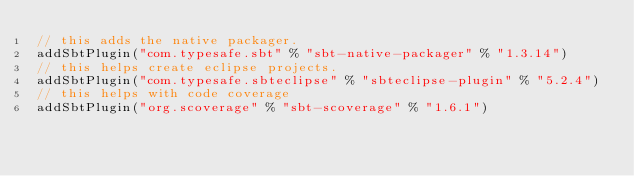Convert code to text. <code><loc_0><loc_0><loc_500><loc_500><_Scala_>// this adds the native packager.
addSbtPlugin("com.typesafe.sbt" % "sbt-native-packager" % "1.3.14")
// this helps create eclipse projects.
addSbtPlugin("com.typesafe.sbteclipse" % "sbteclipse-plugin" % "5.2.4")
// this helps with code coverage
addSbtPlugin("org.scoverage" % "sbt-scoverage" % "1.6.1")
</code> 